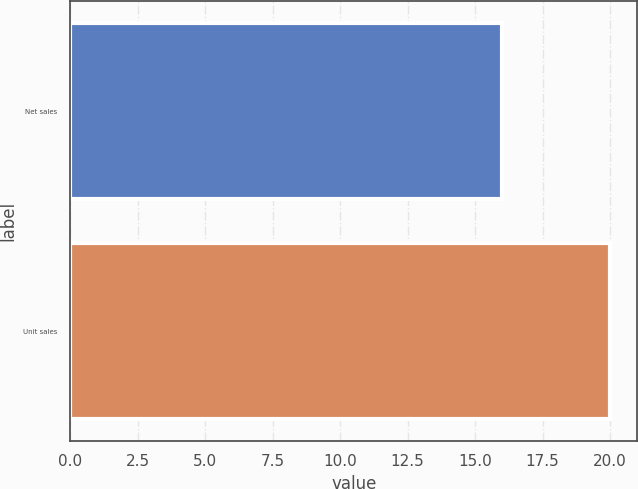<chart> <loc_0><loc_0><loc_500><loc_500><bar_chart><fcel>Net sales<fcel>Unit sales<nl><fcel>16<fcel>20<nl></chart> 